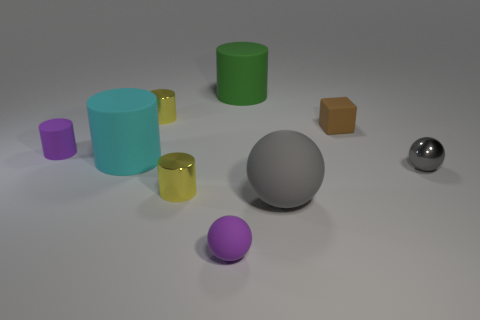Subtract all cyan cylinders. How many cylinders are left? 4 Subtract all purple balls. How many balls are left? 2 Subtract all blocks. How many objects are left? 8 Subtract 1 spheres. How many spheres are left? 2 Add 1 small purple things. How many objects exist? 10 Subtract 0 blue cylinders. How many objects are left? 9 Subtract all green spheres. Subtract all brown cubes. How many spheres are left? 3 Subtract all green balls. How many purple cylinders are left? 1 Subtract all tiny gray shiny spheres. Subtract all matte blocks. How many objects are left? 7 Add 1 large matte spheres. How many large matte spheres are left? 2 